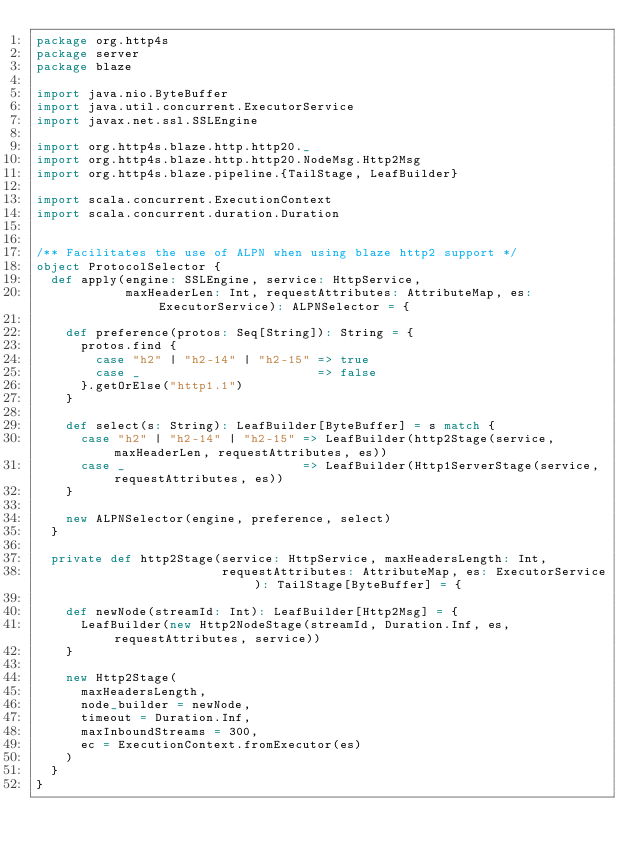Convert code to text. <code><loc_0><loc_0><loc_500><loc_500><_Scala_>package org.http4s
package server
package blaze

import java.nio.ByteBuffer
import java.util.concurrent.ExecutorService
import javax.net.ssl.SSLEngine

import org.http4s.blaze.http.http20._
import org.http4s.blaze.http.http20.NodeMsg.Http2Msg
import org.http4s.blaze.pipeline.{TailStage, LeafBuilder}

import scala.concurrent.ExecutionContext
import scala.concurrent.duration.Duration


/** Facilitates the use of ALPN when using blaze http2 support */
object ProtocolSelector {
  def apply(engine: SSLEngine, service: HttpService,
            maxHeaderLen: Int, requestAttributes: AttributeMap, es: ExecutorService): ALPNSelector = {

    def preference(protos: Seq[String]): String = {
      protos.find {
        case "h2" | "h2-14" | "h2-15" => true
        case _                        => false
      }.getOrElse("http1.1")
    }

    def select(s: String): LeafBuilder[ByteBuffer] = s match {
      case "h2" | "h2-14" | "h2-15" => LeafBuilder(http2Stage(service, maxHeaderLen, requestAttributes, es))
      case _                        => LeafBuilder(Http1ServerStage(service, requestAttributes, es))
    }

    new ALPNSelector(engine, preference, select)
  }

  private def http2Stage(service: HttpService, maxHeadersLength: Int,
                         requestAttributes: AttributeMap, es: ExecutorService): TailStage[ByteBuffer] = {

    def newNode(streamId: Int): LeafBuilder[Http2Msg] = {
      LeafBuilder(new Http2NodeStage(streamId, Duration.Inf, es, requestAttributes, service))
    }

    new Http2Stage(
      maxHeadersLength,
      node_builder = newNode,
      timeout = Duration.Inf,
      maxInboundStreams = 300,
      ec = ExecutionContext.fromExecutor(es)
    )
  }
}</code> 